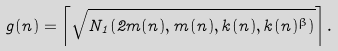<formula> <loc_0><loc_0><loc_500><loc_500>g ( n ) = \left \lceil \sqrt { N _ { 1 } ( 2 m ( n ) , m ( n ) , k ( n ) , k ( n ) ^ { \beta } ) } \right \rceil .</formula> 